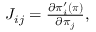<formula> <loc_0><loc_0><loc_500><loc_500>\begin{array} { r } { J _ { i j } = \frac { \partial \pi _ { i } ^ { \prime } ( { \boldsymbol \pi } ) } { \partial { \pi _ { j } } } , } \end{array}</formula> 